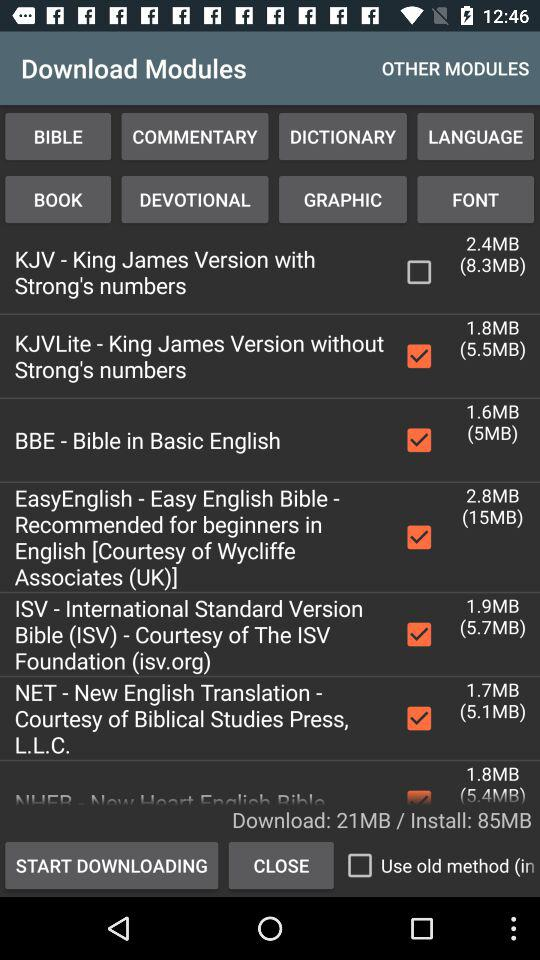What is the status of ISV? The status of ISV is on. 